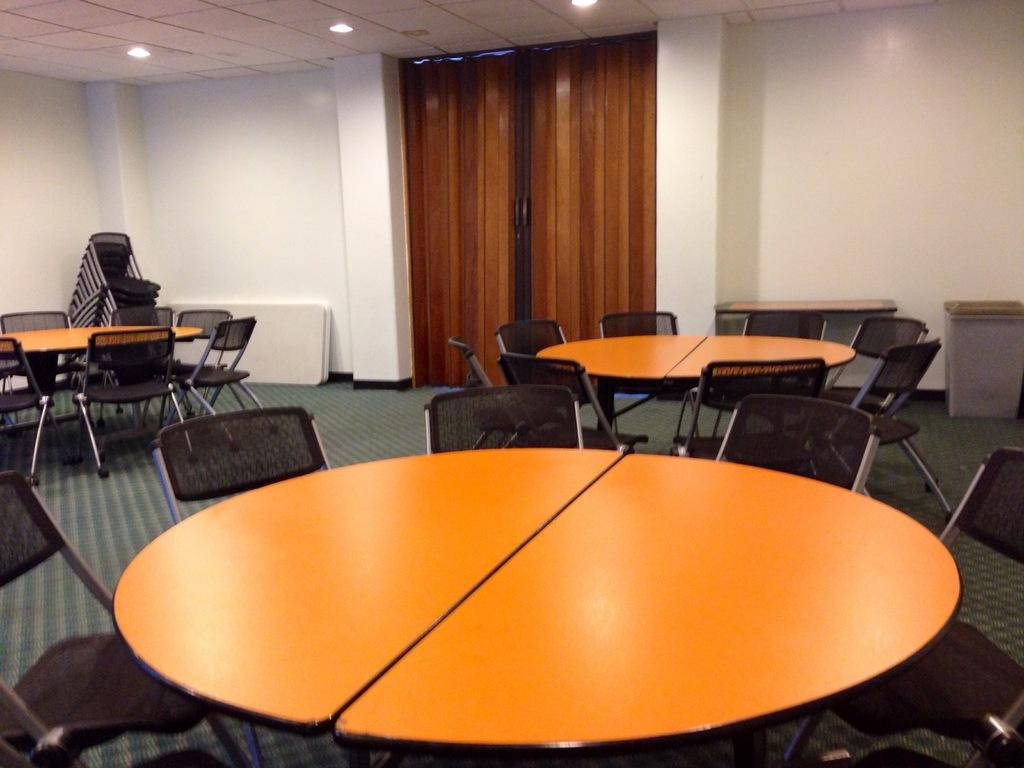What type of table is in the image? There is a wooden round table in the image. Where is the table located? The table is placed in a hall. What color are the chairs around the table? The chairs around the table are black. What can be seen on the walls in the background of the image? There is a white color wall in the background of the image. What type of window treatment is present in the background of the image? There is a brown curtain in the background of the image. What type of needle is being used by the spy in the image? There is no needle or spy present in the image. What value does the table hold in the image? The value of the table cannot be determined from the image alone, as it is a static object. 